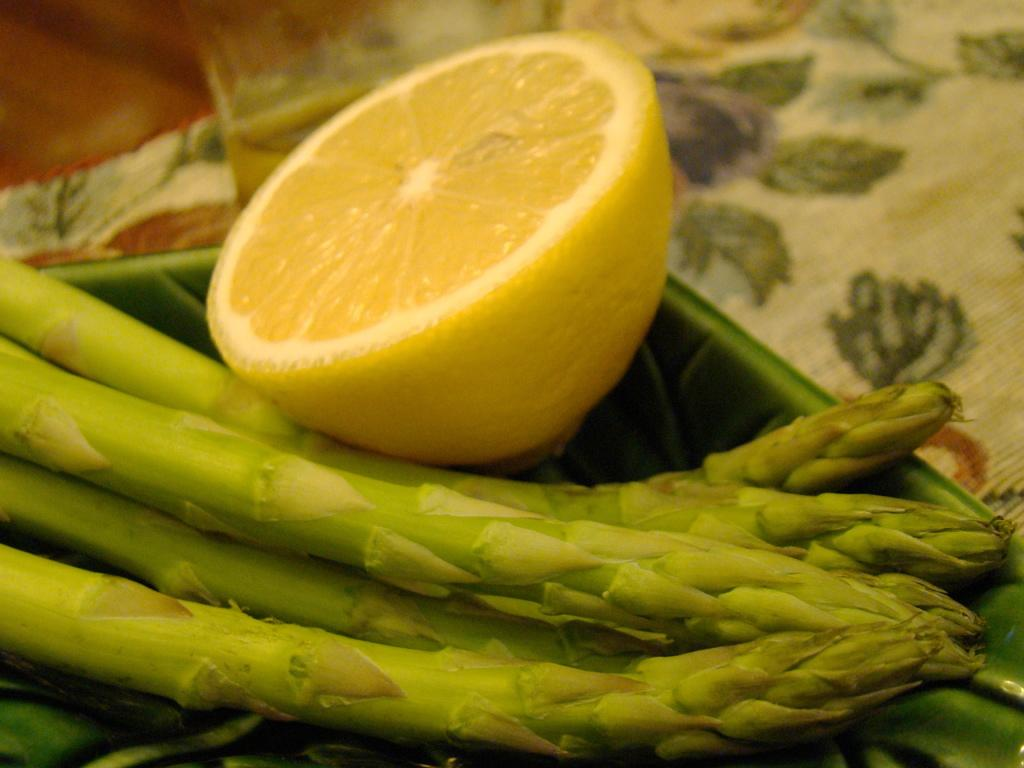What piece of furniture is visible in the image? There is a table in the image. What is placed on the table? There is a tray on the table. What type of food can be seen on the tray? Asparagus is present on the tray. Are there any additional items on the tray? Yes, there is a lemon slice on the tray. What type of flower is growing on the table in the image? There are no flowers present on the table in the image; it only contains a tray with asparagus and a lemon slice. 